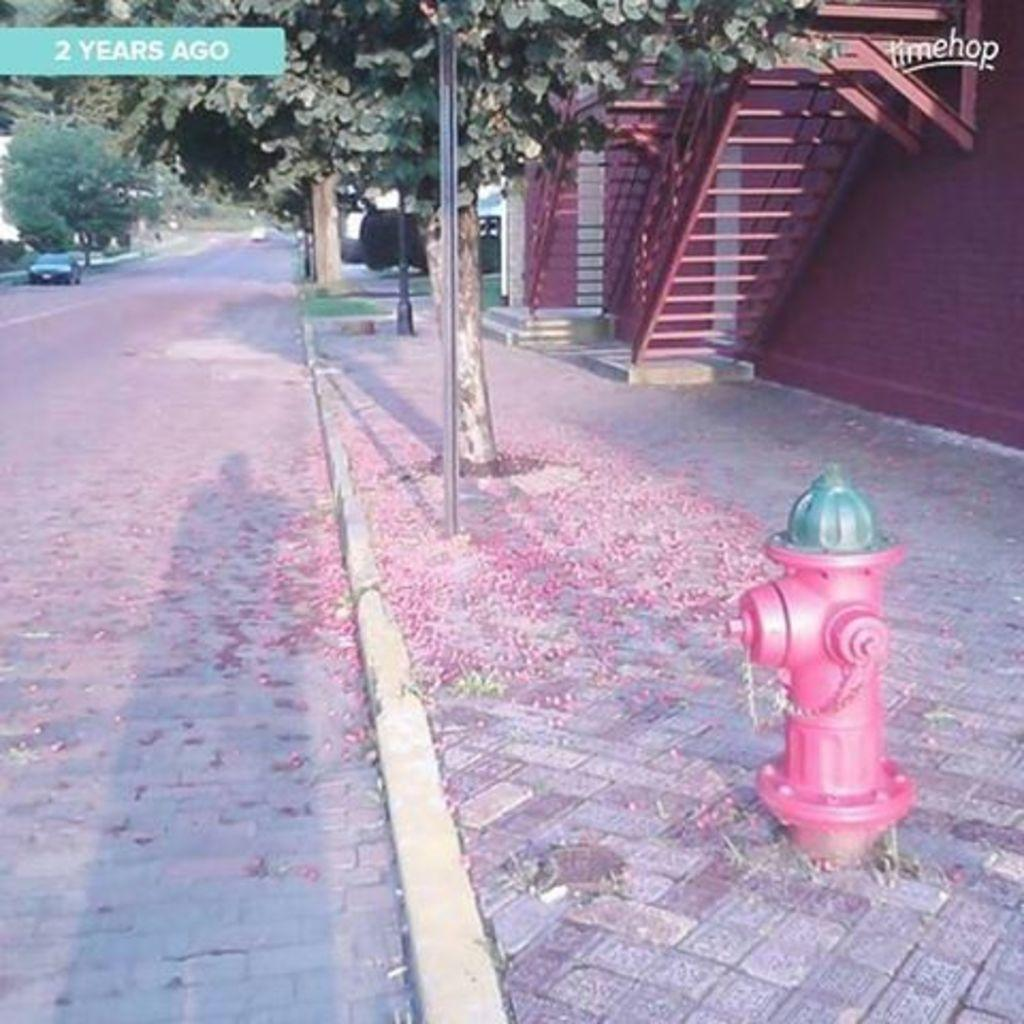What object is located on the right side of the image? There is a fire hydrant on the right side of the image. What architectural feature is also on the right side of the image? There is a staircase on the right side of the image. What vehicle can be seen on the left side of the image? There is a car on the left side of the image. What type of natural scenery is visible in the background of the image? There are trees in the background of the image. What type of disease is affecting the bear in the image? There is no bear present in the image, so it is not possible to determine if a disease is affecting it. 